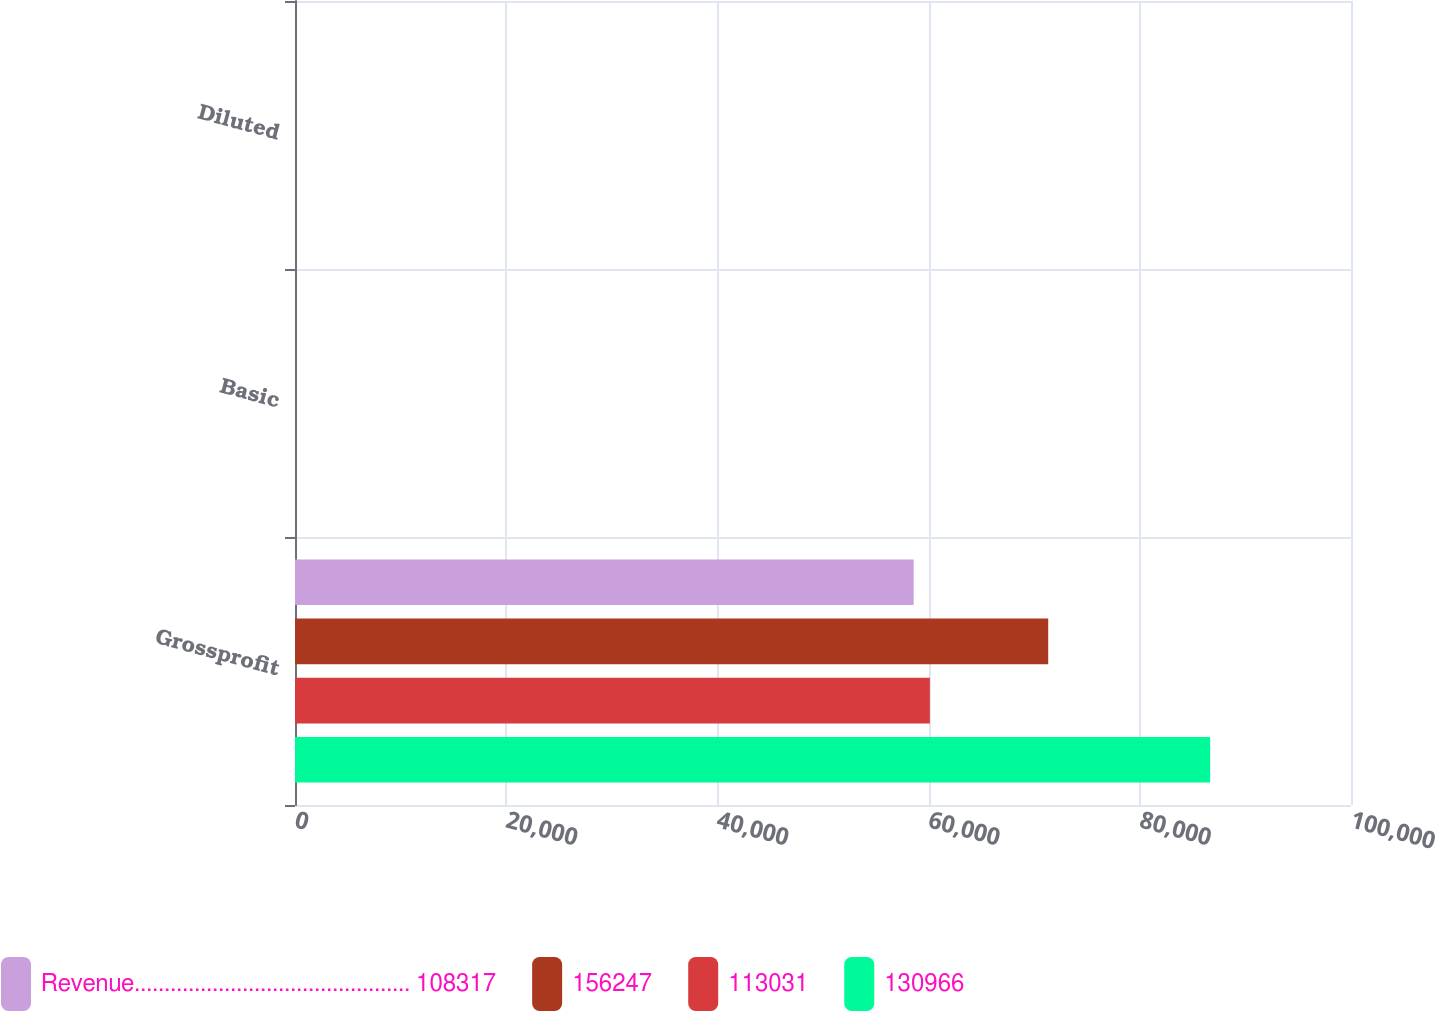Convert chart. <chart><loc_0><loc_0><loc_500><loc_500><stacked_bar_chart><ecel><fcel>Grossprofit<fcel>Basic<fcel>Diluted<nl><fcel>Revenue.............................................. 108317<fcel>58586<fcel>0.21<fcel>0.19<nl><fcel>156247<fcel>71327<fcel>0.35<fcel>0.31<nl><fcel>113031<fcel>60120<fcel>0.25<fcel>0.22<nl><fcel>130966<fcel>86661<fcel>0.49<fcel>0.43<nl></chart> 